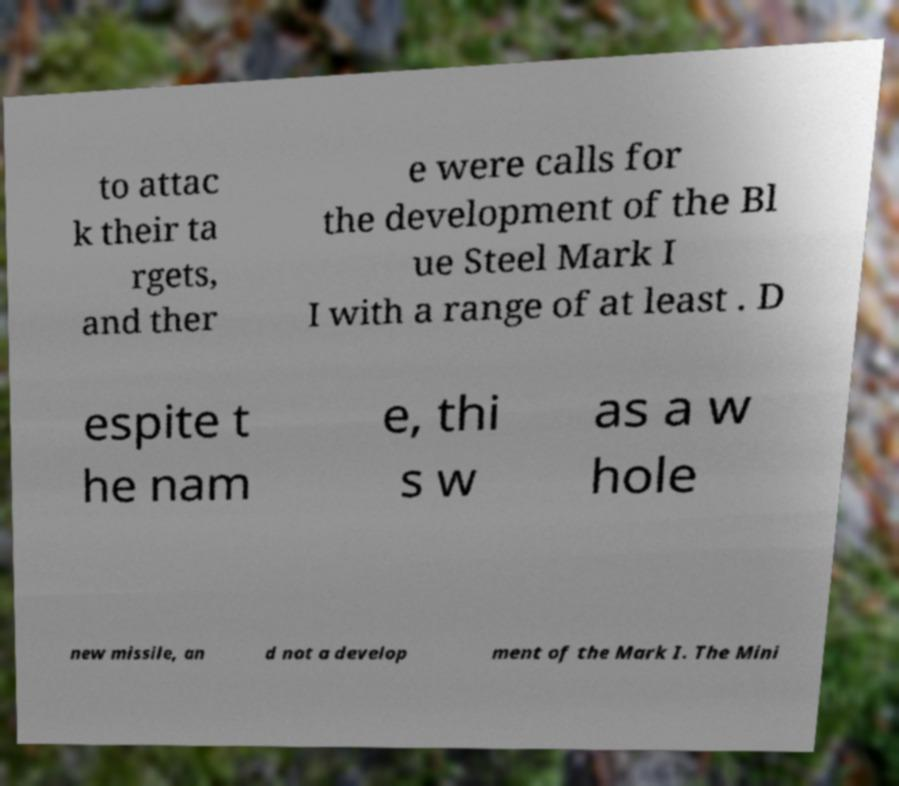Can you accurately transcribe the text from the provided image for me? to attac k their ta rgets, and ther e were calls for the development of the Bl ue Steel Mark I I with a range of at least . D espite t he nam e, thi s w as a w hole new missile, an d not a develop ment of the Mark I. The Mini 